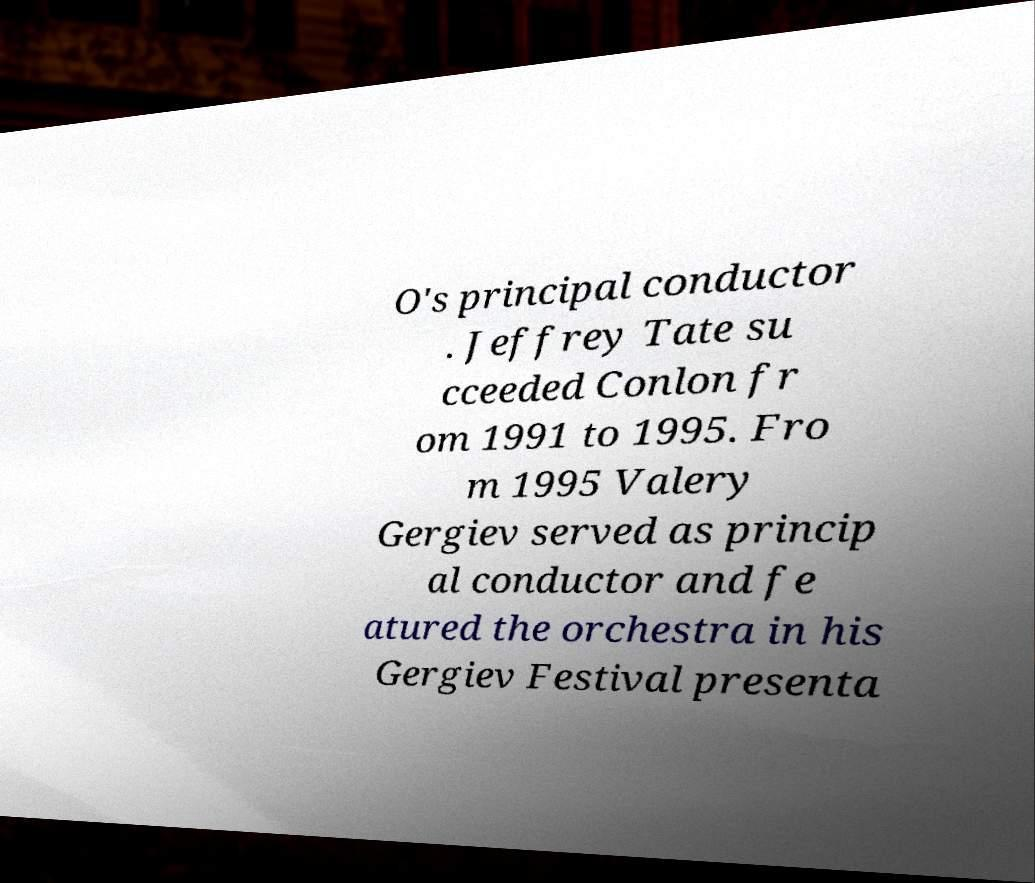I need the written content from this picture converted into text. Can you do that? O's principal conductor . Jeffrey Tate su cceeded Conlon fr om 1991 to 1995. Fro m 1995 Valery Gergiev served as princip al conductor and fe atured the orchestra in his Gergiev Festival presenta 